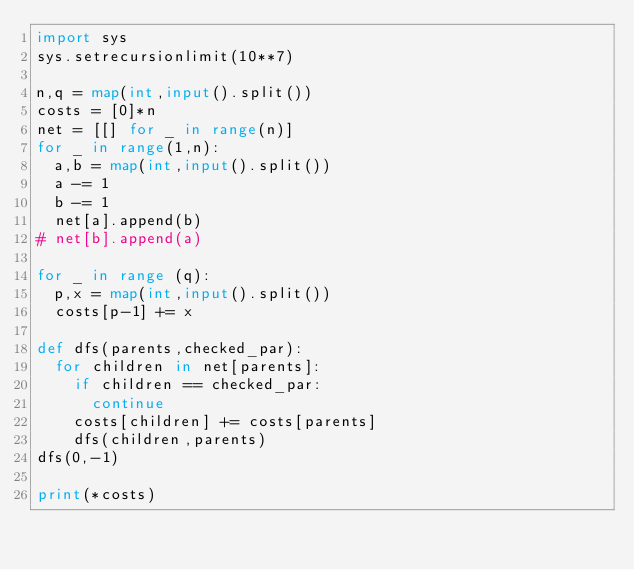<code> <loc_0><loc_0><loc_500><loc_500><_Python_>import sys
sys.setrecursionlimit(10**7)

n,q = map(int,input().split())
costs = [0]*n
net = [[] for _ in range(n)]
for _ in range(1,n):
	a,b = map(int,input().split())	
	a -= 1
	b -= 1
	net[a].append(b)
#	net[b].append(a)
	
for _ in range (q):
	p,x = map(int,input().split())
	costs[p-1] += x

def dfs(parents,checked_par):
	for children in net[parents]:
		if children == checked_par:
			continue
		costs[children] += costs[parents]
		dfs(children,parents)
dfs(0,-1)

print(*costs)
</code> 